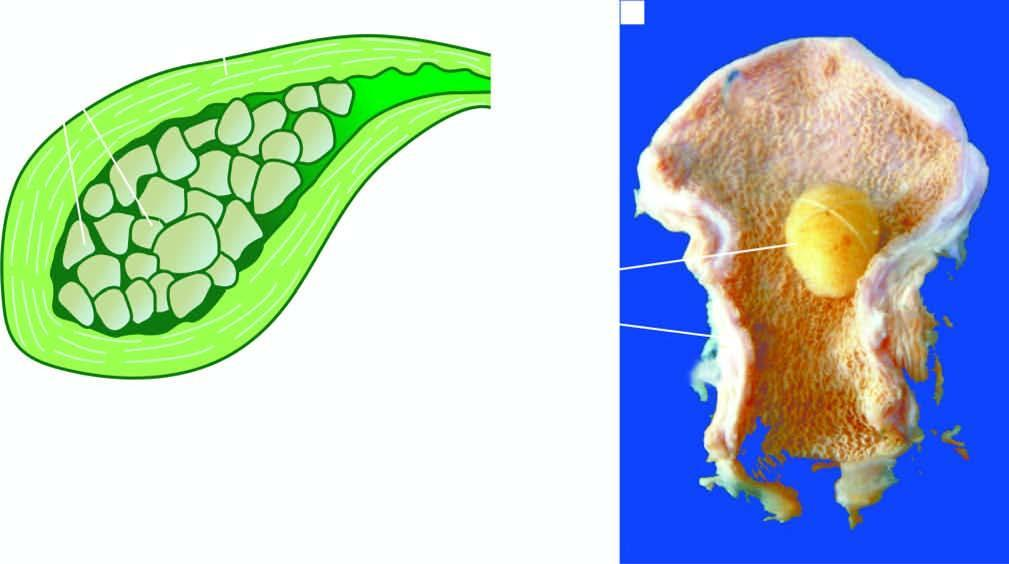what does the lumen contain?
Answer the question using a single word or phrase. A single 